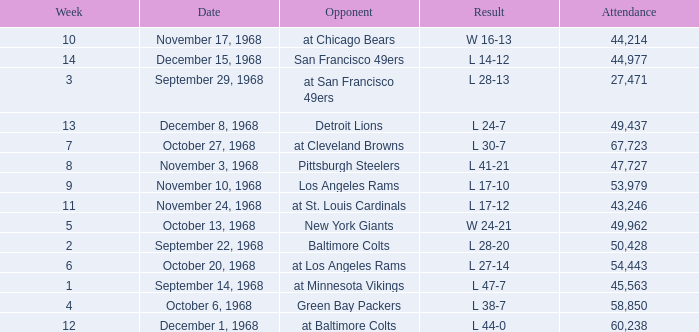Which Attendance has a Date of september 29, 1968, and a Week smaller than 3? None. 